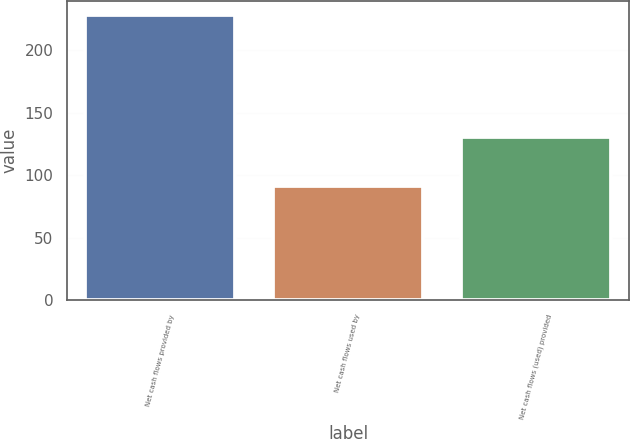Convert chart. <chart><loc_0><loc_0><loc_500><loc_500><bar_chart><fcel>Net cash flows provided by<fcel>Net cash flows used by<fcel>Net cash flows (used) provided<nl><fcel>227.6<fcel>91.5<fcel>130.8<nl></chart> 